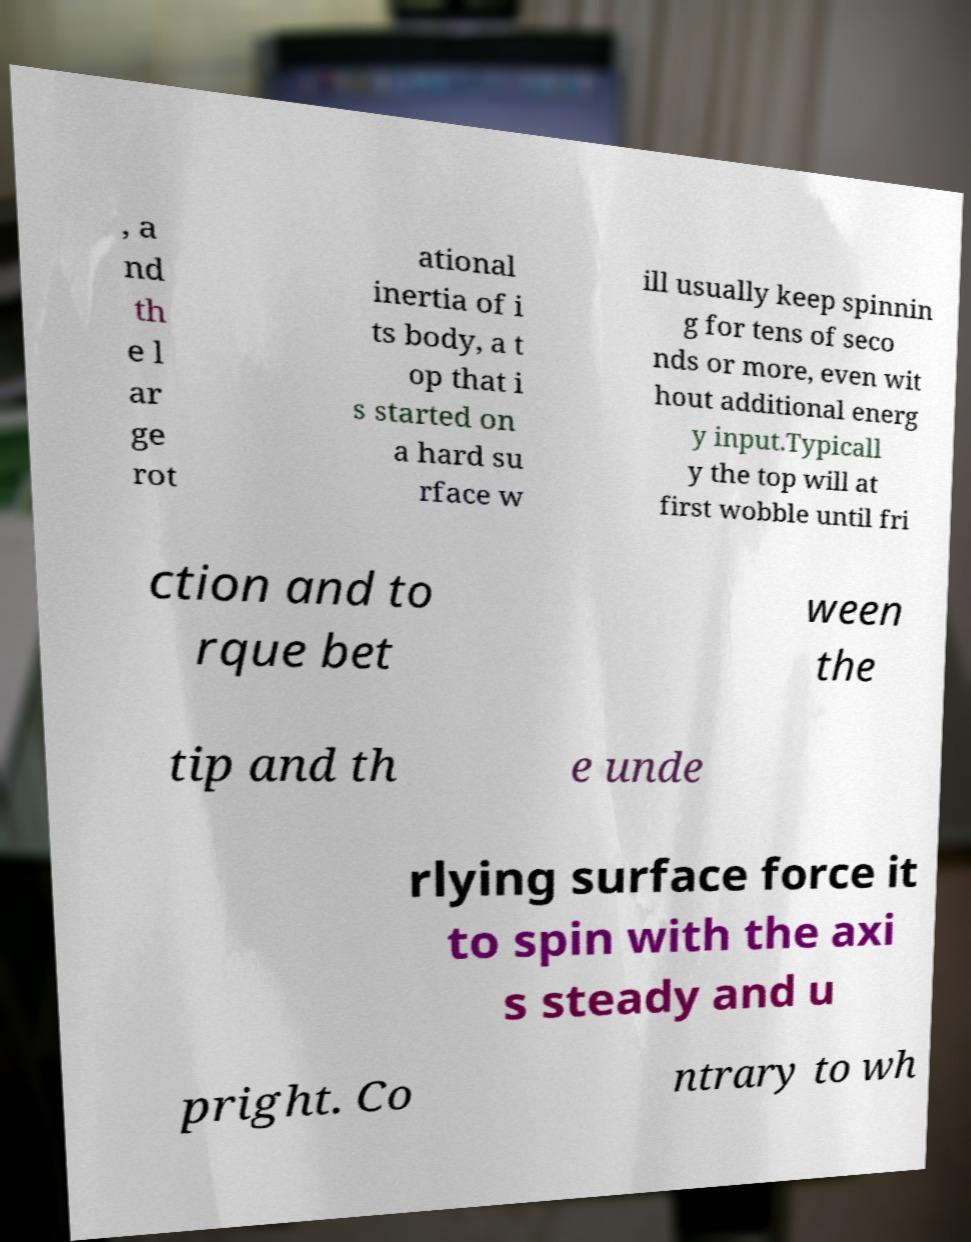Could you extract and type out the text from this image? , a nd th e l ar ge rot ational inertia of i ts body, a t op that i s started on a hard su rface w ill usually keep spinnin g for tens of seco nds or more, even wit hout additional energ y input.Typicall y the top will at first wobble until fri ction and to rque bet ween the tip and th e unde rlying surface force it to spin with the axi s steady and u pright. Co ntrary to wh 